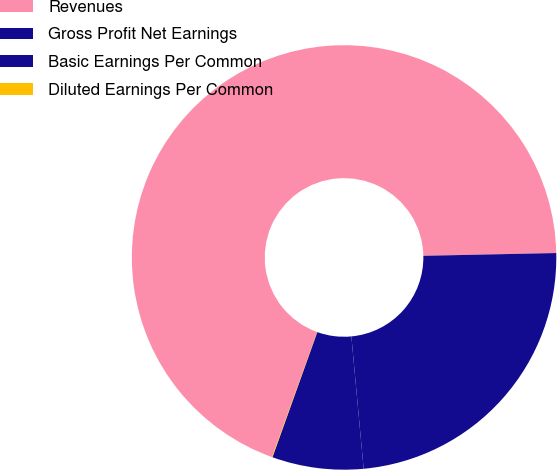Convert chart to OTSL. <chart><loc_0><loc_0><loc_500><loc_500><pie_chart><fcel>Revenues<fcel>Gross Profit Net Earnings<fcel>Basic Earnings Per Common<fcel>Diluted Earnings Per Common<nl><fcel>69.15%<fcel>23.86%<fcel>6.95%<fcel>0.04%<nl></chart> 